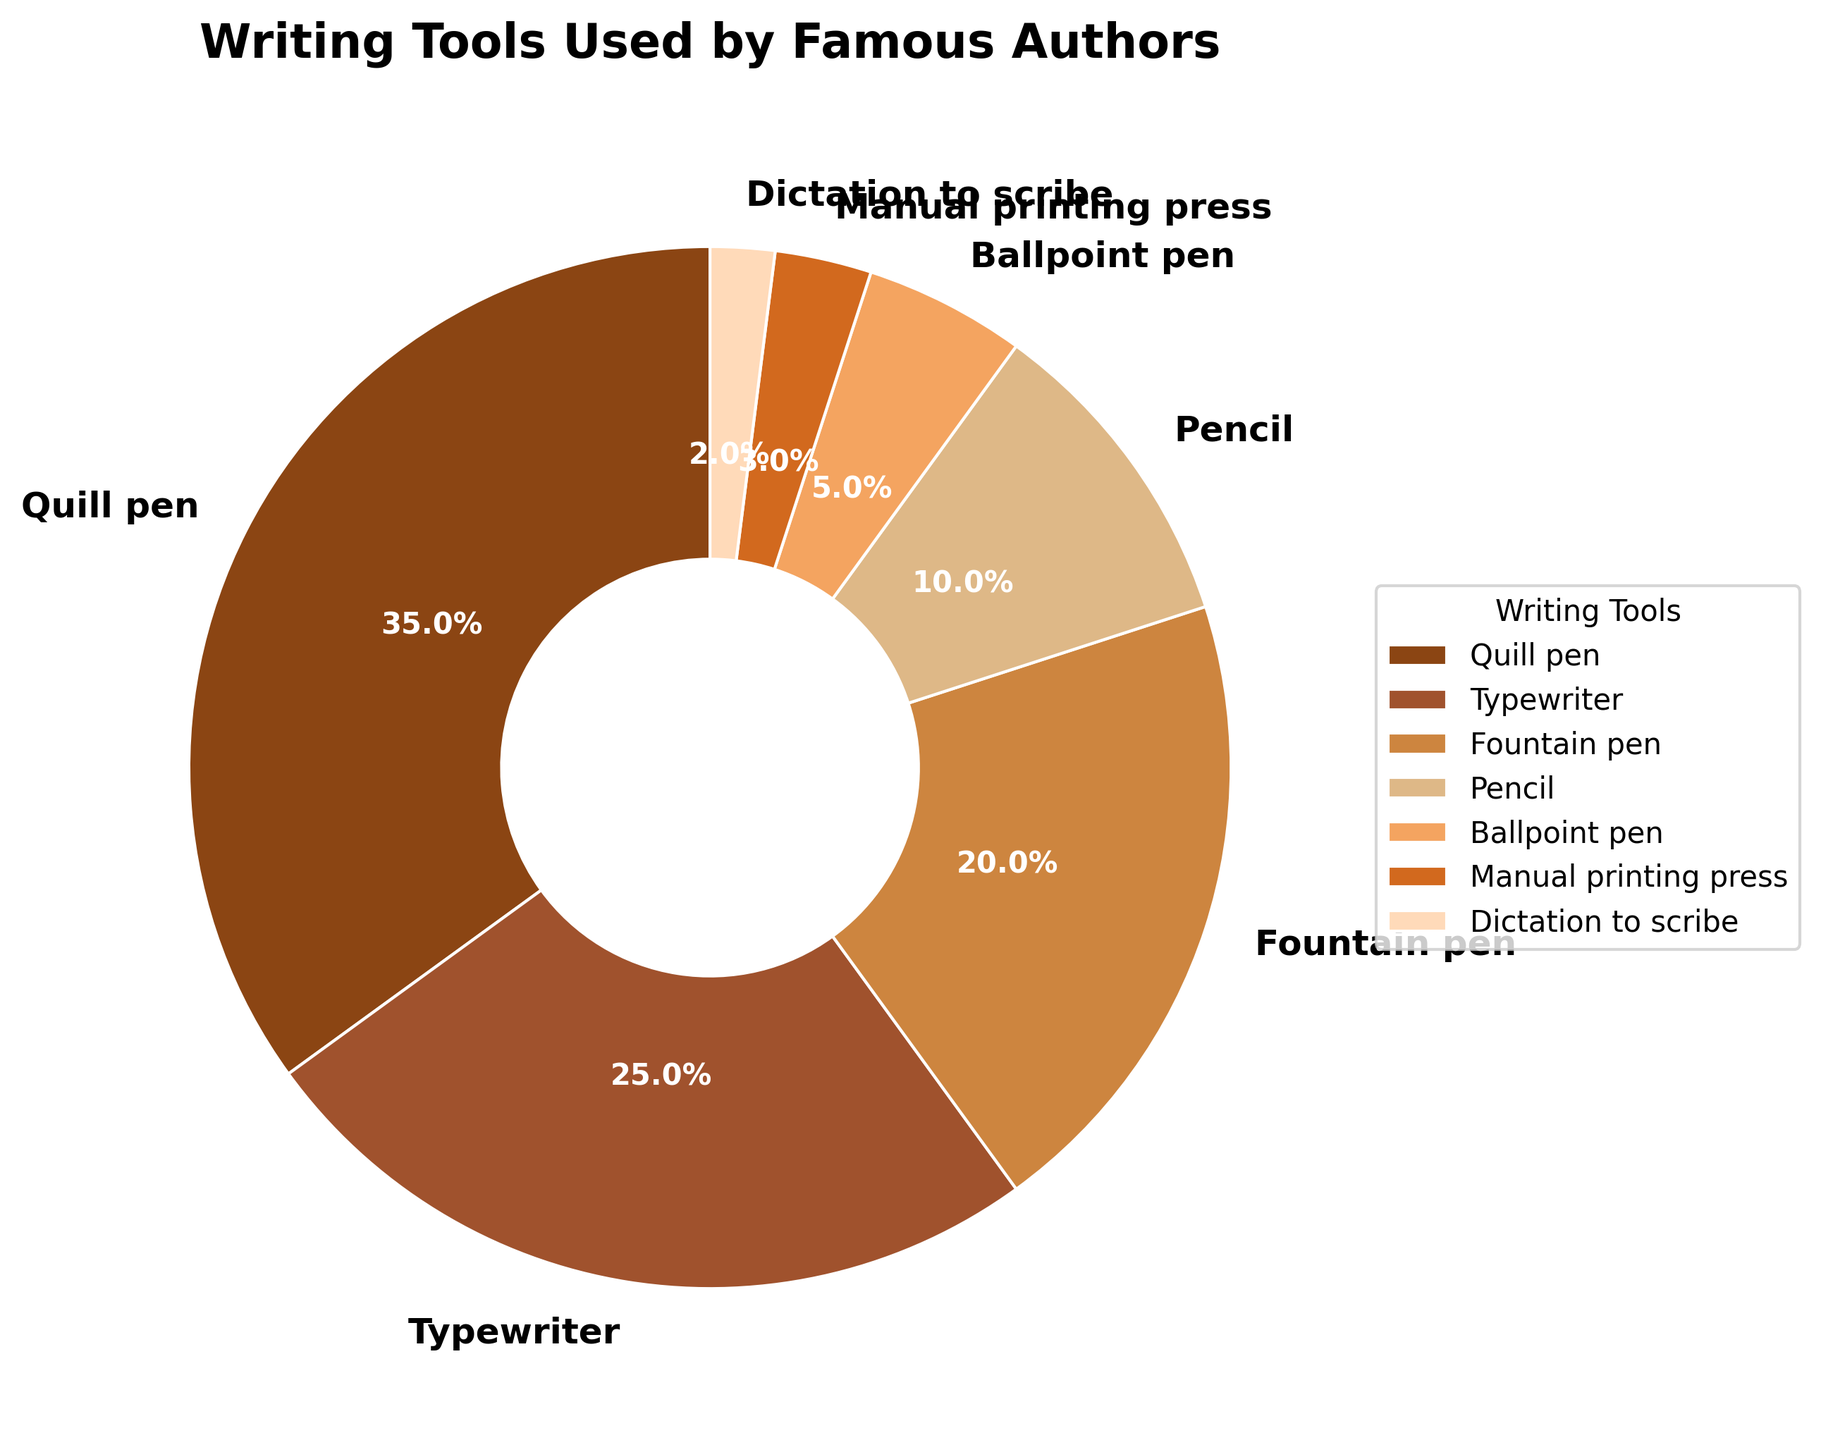Which writing tool was used the most by famous authors? We can see the pie chart segment with the largest percentage, labeled "Quill pen", representing 35%.
Answer: Quill pen What is the total percentage of authors who used either the typewriter or the fountain pen? Add the percentages for "Typewriter" and "Fountain pen". Typewriter is 25% and Fountain pen is 20%. Therefore, 25% + 20% = 45%.
Answer: 45% Which writing tool was used more, the pencil or the ballpoint pen? Compare the percentages for "Pencil" (10%) and "Ballpoint pen" (5%). Pencil has a higher percentage.
Answer: Pencil What percentage of authors used tools other than the quill pen and typewriter? Subtract the sum of the percentages for "Quill pen" and "Typewriter" from 100%. Total percentage for Quill pen and Typewriter is 35% + 25% = 60%. Hence, 100% - 60% = 40%.
Answer: 40% What is the difference in the percentage of authors who used a quill pen and those who used a fountain pen? Subtract the percentage for "Fountain pen" from the percentage for "Quill pen". Quill pen is 35%, Fountain pen is 20%, so 35% - 20% = 15%.
Answer: 15% Which writing tool has the smallest percentage of use among famous authors? Identify the smallest segment percentage in the pie chart, which is "Dictation to scribe" at 2%.
Answer: Dictation to scribe Considering all authors who did not use a quill pen, what is the average percentage use of the other tools? Exclude Quill pen (35%) and sum the remaining percentages: 25% + 20% + 10% + 5% + 3% + 2% = 65%. There are six other tools. Therefore, 65% / 6 ≈ 10.83%.
Answer: 10.83% If we combined the percentages of typewriter and manual printing press, would it exceed the usage of a quill pen? Adding the percentages for "Typewriter" (25%) and "Manual printing press" (3%) gives 25% + 3% = 28%, which is less than 35% for the Quill pen.
Answer: No Are more authors likely to have used either a fountain pen or a pencil compared to a typewriter? Sum the percentages of "Fountain pen" (20%) and "Pencil" (10%) which gives 20% + 10% = 30%. Compare this to the percentage of "Typewriter" which is 25%. 30% is greater than 25%.
Answer: Yes Which writing tools have a combined usage exceeding 50%? Adding progressively to find when the combined total exceeds 50%. "Quill pen" (35%) + "Typewriter" (25%) = 60%, which exceeds 50%.
Answer: Quill pen and Typewriter 